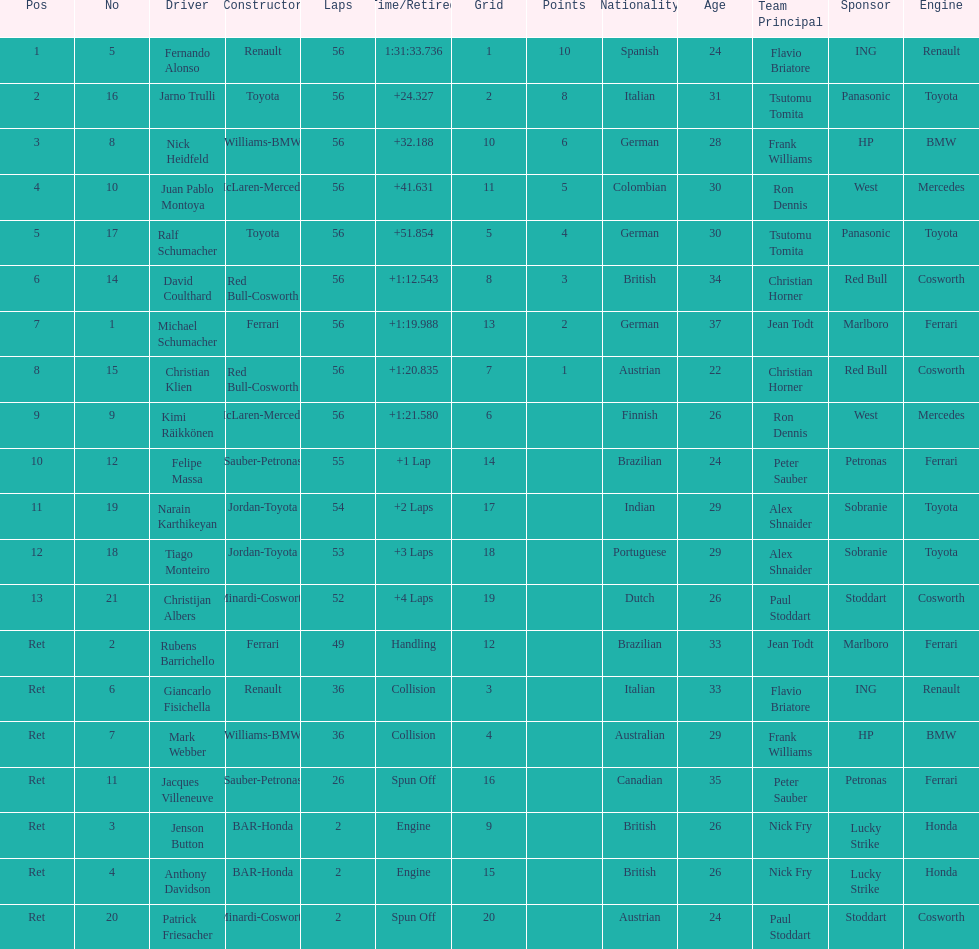Give me the full table as a dictionary. {'header': ['Pos', 'No', 'Driver', 'Constructor', 'Laps', 'Time/Retired', 'Grid', 'Points', 'Nationality', 'Age', 'Team Principal', 'Sponsor', 'Engine'], 'rows': [['1', '5', 'Fernando Alonso', 'Renault', '56', '1:31:33.736', '1', '10', 'Spanish', '24', 'Flavio Briatore', 'ING', 'Renault'], ['2', '16', 'Jarno Trulli', 'Toyota', '56', '+24.327', '2', '8', 'Italian', '31', 'Tsutomu Tomita', 'Panasonic', 'Toyota'], ['3', '8', 'Nick Heidfeld', 'Williams-BMW', '56', '+32.188', '10', '6', 'German', '28', 'Frank Williams', 'HP', 'BMW'], ['4', '10', 'Juan Pablo Montoya', 'McLaren-Mercedes', '56', '+41.631', '11', '5', 'Colombian', '30', 'Ron Dennis', 'West', 'Mercedes'], ['5', '17', 'Ralf Schumacher', 'Toyota', '56', '+51.854', '5', '4', 'German', '30', 'Tsutomu Tomita', 'Panasonic', 'Toyota'], ['6', '14', 'David Coulthard', 'Red Bull-Cosworth', '56', '+1:12.543', '8', '3', 'British', '34', 'Christian Horner', 'Red Bull', 'Cosworth'], ['7', '1', 'Michael Schumacher', 'Ferrari', '56', '+1:19.988', '13', '2', 'German', '37', 'Jean Todt', 'Marlboro', 'Ferrari'], ['8', '15', 'Christian Klien', 'Red Bull-Cosworth', '56', '+1:20.835', '7', '1', 'Austrian', '22', 'Christian Horner', 'Red Bull', 'Cosworth'], ['9', '9', 'Kimi Räikkönen', 'McLaren-Mercedes', '56', '+1:21.580', '6', '', 'Finnish', '26', 'Ron Dennis', 'West', 'Mercedes'], ['10', '12', 'Felipe Massa', 'Sauber-Petronas', '55', '+1 Lap', '14', '', 'Brazilian', '24', 'Peter Sauber', 'Petronas', 'Ferrari'], ['11', '19', 'Narain Karthikeyan', 'Jordan-Toyota', '54', '+2 Laps', '17', '', 'Indian', '29', 'Alex Shnaider', 'Sobranie', 'Toyota'], ['12', '18', 'Tiago Monteiro', 'Jordan-Toyota', '53', '+3 Laps', '18', '', 'Portuguese', '29', 'Alex Shnaider', 'Sobranie', 'Toyota'], ['13', '21', 'Christijan Albers', 'Minardi-Cosworth', '52', '+4 Laps', '19', '', 'Dutch', '26', 'Paul Stoddart', 'Stoddart', 'Cosworth'], ['Ret', '2', 'Rubens Barrichello', 'Ferrari', '49', 'Handling', '12', '', 'Brazilian', '33', 'Jean Todt', 'Marlboro', 'Ferrari'], ['Ret', '6', 'Giancarlo Fisichella', 'Renault', '36', 'Collision', '3', '', 'Italian', '33', 'Flavio Briatore', 'ING', 'Renault'], ['Ret', '7', 'Mark Webber', 'Williams-BMW', '36', 'Collision', '4', '', 'Australian', '29', 'Frank Williams', 'HP', 'BMW'], ['Ret', '11', 'Jacques Villeneuve', 'Sauber-Petronas', '26', 'Spun Off', '16', '', 'Canadian', '35', 'Peter Sauber', 'Petronas', 'Ferrari'], ['Ret', '3', 'Jenson Button', 'BAR-Honda', '2', 'Engine', '9', '', 'British', '26', 'Nick Fry', 'Lucky Strike', 'Honda'], ['Ret', '4', 'Anthony Davidson', 'BAR-Honda', '2', 'Engine', '15', '', 'British', '26', 'Nick Fry', 'Lucky Strike', 'Honda'], ['Ret', '20', 'Patrick Friesacher', 'Minardi-Cosworth', '2', 'Spun Off', '20', '', 'Austrian', '24', 'Paul Stoddart', 'Stoddart', 'Cosworth']]} Who was the last driver to actually finish the race? Christijan Albers. 